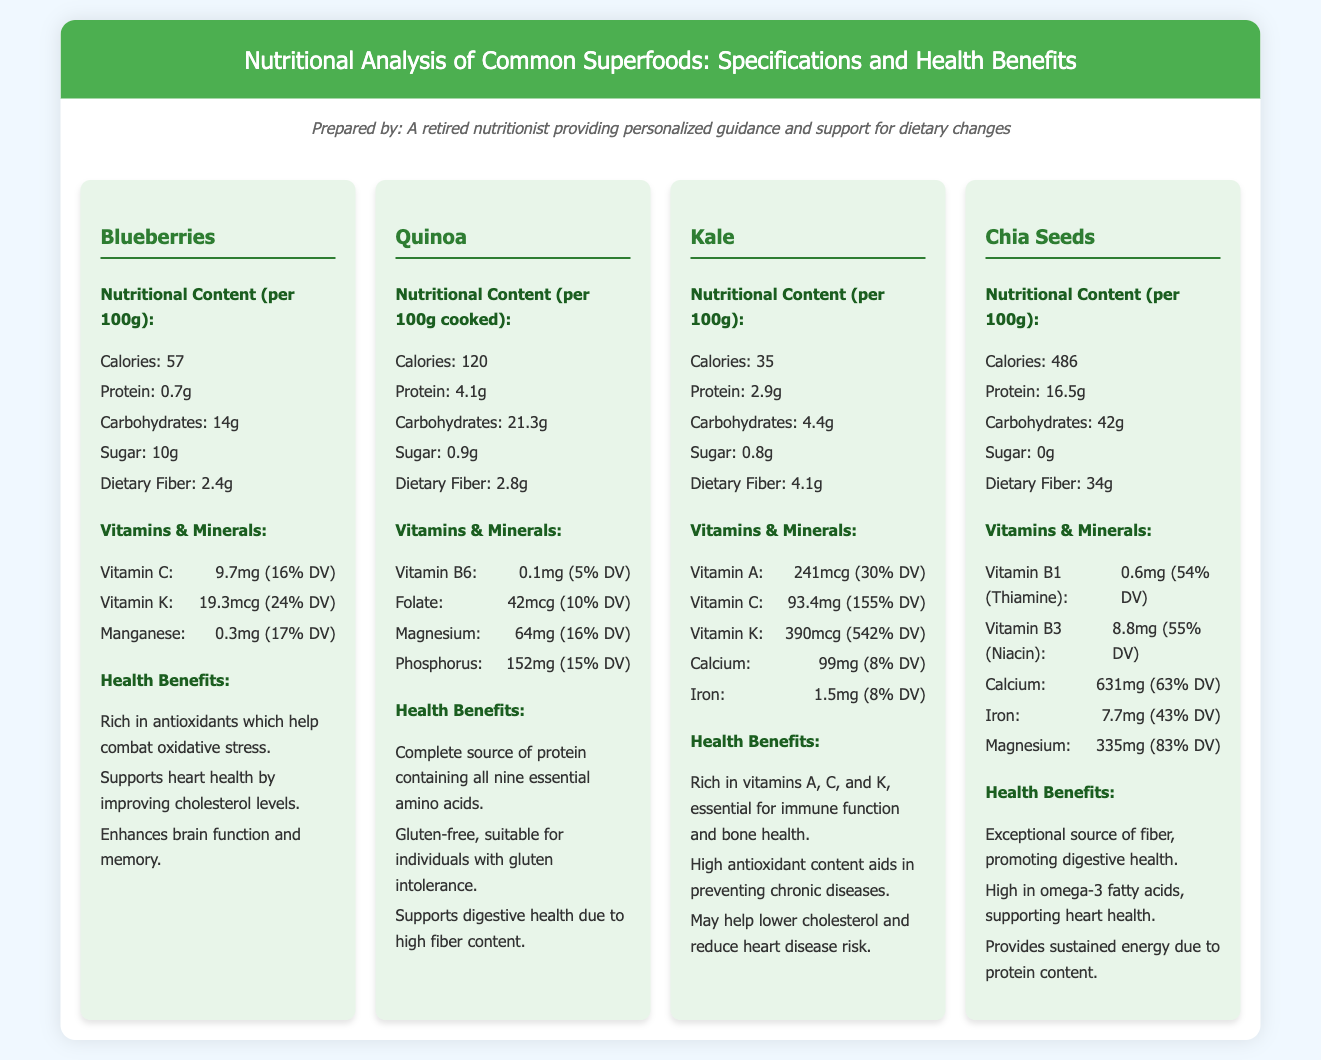What is the caloric content of blueberries? The caloric content is listed in the nutritional content section of the document for blueberries per 100g, which is 57.
Answer: 57 What is the dietary fiber in quinoa? The dietary fiber is mentioned under the nutritional content section for quinoa, which states it has 2.8g per 100g cooked.
Answer: 2.8g Which vitamin in kale has the highest percentage of daily value? The vitamin K in kale contains 390mcg, which is 542% of the Daily Value as stated in the vitamins & minerals section.
Answer: Vitamin K What are the health benefits of chia seeds? The health benefits include several points outlined in the health benefits section, one of which is its promotion of digestive health due to fiber.
Answer: Digestive health What is the protein content in chia seeds? The protein content is found in the nutritional content section of the document for chia seeds per 100g, which is 16.5g.
Answer: 16.5g Which superfood is gluten-free? The document specifies that quinoa is gluten-free in its health benefits section.
Answer: Quinoa How many vitamins and minerals are listed for kale? The vitamins and minerals section provides a total of five specific vitamins and minerals for kale.
Answer: 5 How does the caloric content of chia seeds compare to blueberries? By comparing the two nutritional content sections, chia seeds have 486 calories while blueberries have 57 calories.
Answer: Higher What is the daily value percentage for Vitamin C in kale? The document states that Vitamin C provides 155% of the Daily Value in kale.
Answer: 155% 